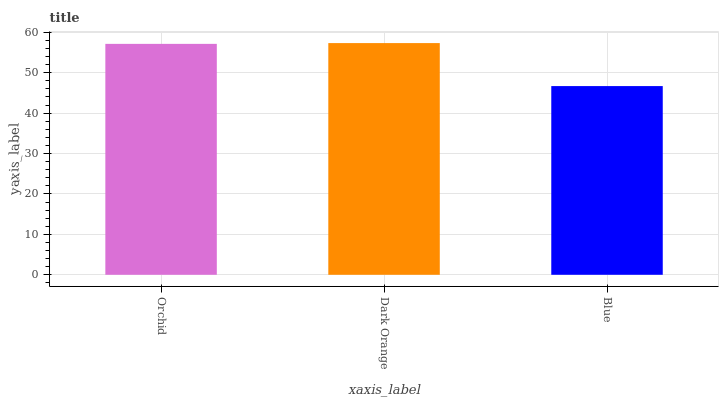Is Blue the minimum?
Answer yes or no. Yes. Is Dark Orange the maximum?
Answer yes or no. Yes. Is Dark Orange the minimum?
Answer yes or no. No. Is Blue the maximum?
Answer yes or no. No. Is Dark Orange greater than Blue?
Answer yes or no. Yes. Is Blue less than Dark Orange?
Answer yes or no. Yes. Is Blue greater than Dark Orange?
Answer yes or no. No. Is Dark Orange less than Blue?
Answer yes or no. No. Is Orchid the high median?
Answer yes or no. Yes. Is Orchid the low median?
Answer yes or no. Yes. Is Blue the high median?
Answer yes or no. No. Is Dark Orange the low median?
Answer yes or no. No. 